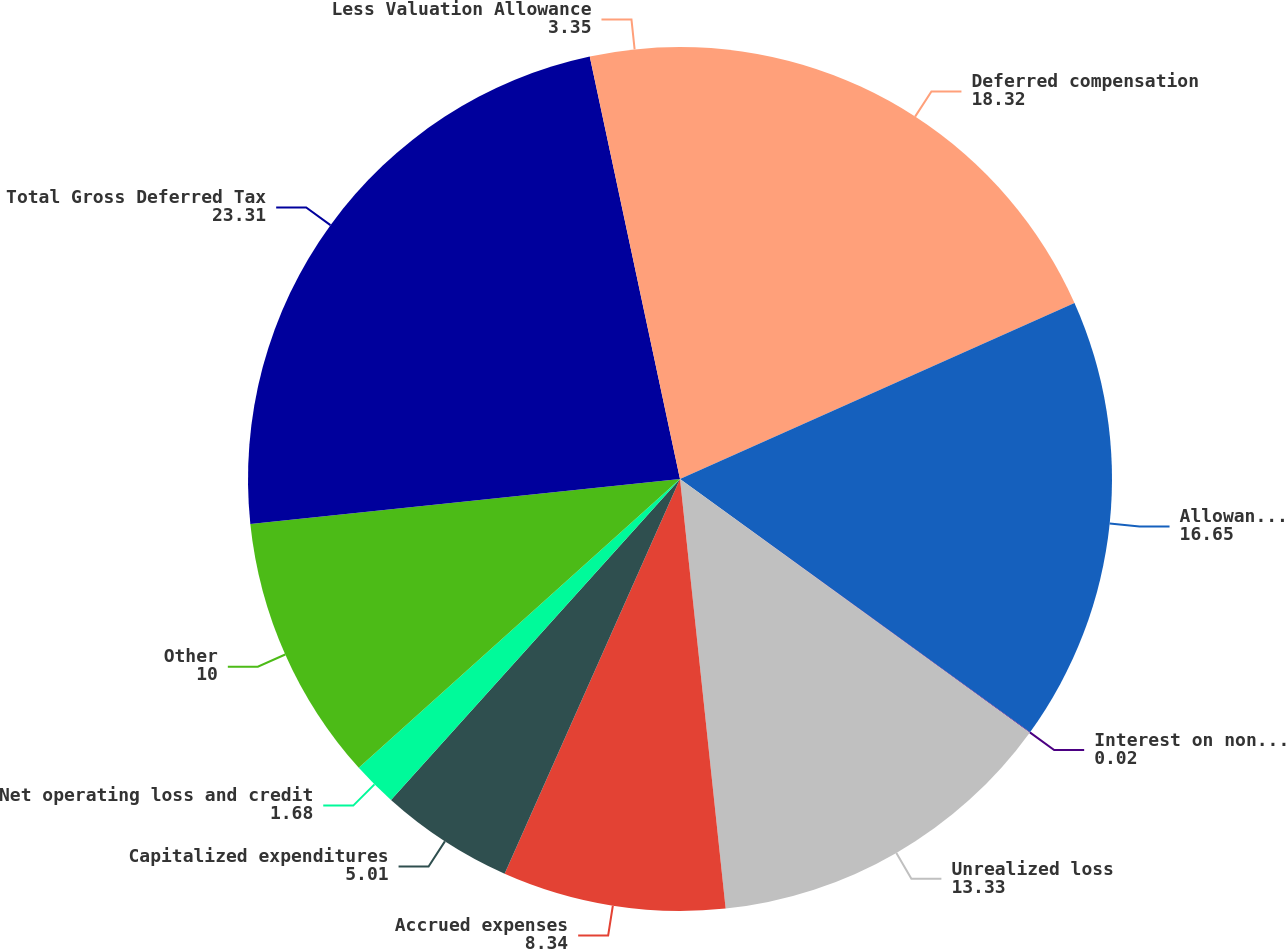Convert chart to OTSL. <chart><loc_0><loc_0><loc_500><loc_500><pie_chart><fcel>Deferred compensation<fcel>Allowances for loan losses and<fcel>Interest on nonaccrual loans<fcel>Unrealized loss<fcel>Accrued expenses<fcel>Capitalized expenditures<fcel>Net operating loss and credit<fcel>Other<fcel>Total Gross Deferred Tax<fcel>Less Valuation Allowance<nl><fcel>18.32%<fcel>16.65%<fcel>0.02%<fcel>13.33%<fcel>8.34%<fcel>5.01%<fcel>1.68%<fcel>10.0%<fcel>23.31%<fcel>3.35%<nl></chart> 